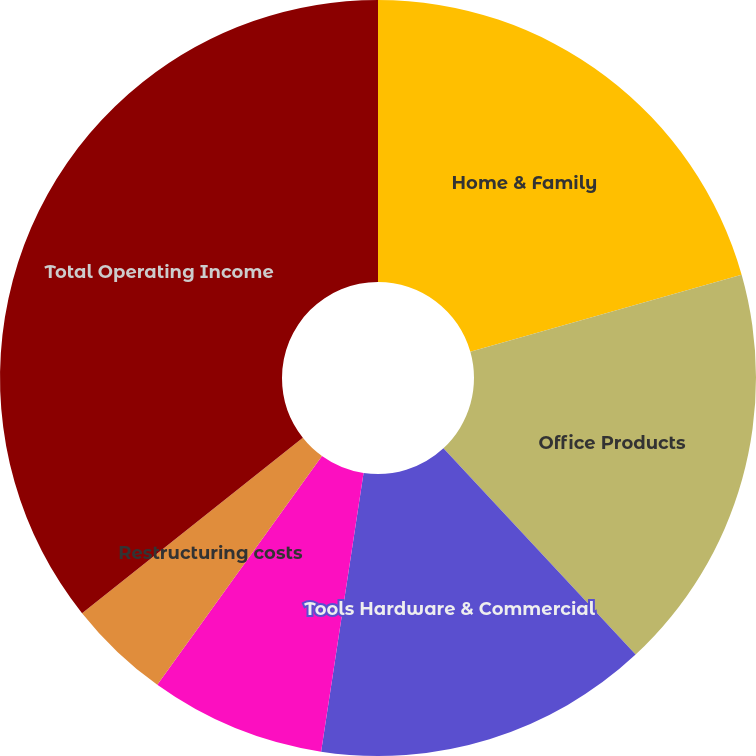<chart> <loc_0><loc_0><loc_500><loc_500><pie_chart><fcel>Home & Family<fcel>Office Products<fcel>Tools Hardware & Commercial<fcel>Corporate<fcel>Restructuring costs<fcel>Total Operating Income<nl><fcel>20.6%<fcel>17.47%<fcel>14.34%<fcel>7.52%<fcel>4.39%<fcel>35.69%<nl></chart> 